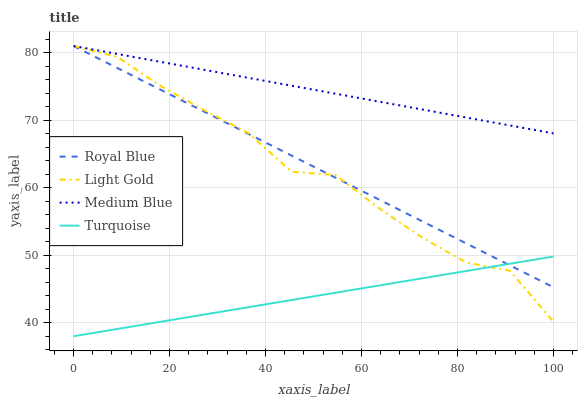Does Turquoise have the minimum area under the curve?
Answer yes or no. Yes. Does Medium Blue have the maximum area under the curve?
Answer yes or no. Yes. Does Light Gold have the minimum area under the curve?
Answer yes or no. No. Does Light Gold have the maximum area under the curve?
Answer yes or no. No. Is Turquoise the smoothest?
Answer yes or no. Yes. Is Light Gold the roughest?
Answer yes or no. Yes. Is Light Gold the smoothest?
Answer yes or no. No. Is Turquoise the roughest?
Answer yes or no. No. Does Turquoise have the lowest value?
Answer yes or no. Yes. Does Light Gold have the lowest value?
Answer yes or no. No. Does Medium Blue have the highest value?
Answer yes or no. Yes. Does Turquoise have the highest value?
Answer yes or no. No. Is Turquoise less than Medium Blue?
Answer yes or no. Yes. Is Medium Blue greater than Turquoise?
Answer yes or no. Yes. Does Turquoise intersect Light Gold?
Answer yes or no. Yes. Is Turquoise less than Light Gold?
Answer yes or no. No. Is Turquoise greater than Light Gold?
Answer yes or no. No. Does Turquoise intersect Medium Blue?
Answer yes or no. No. 